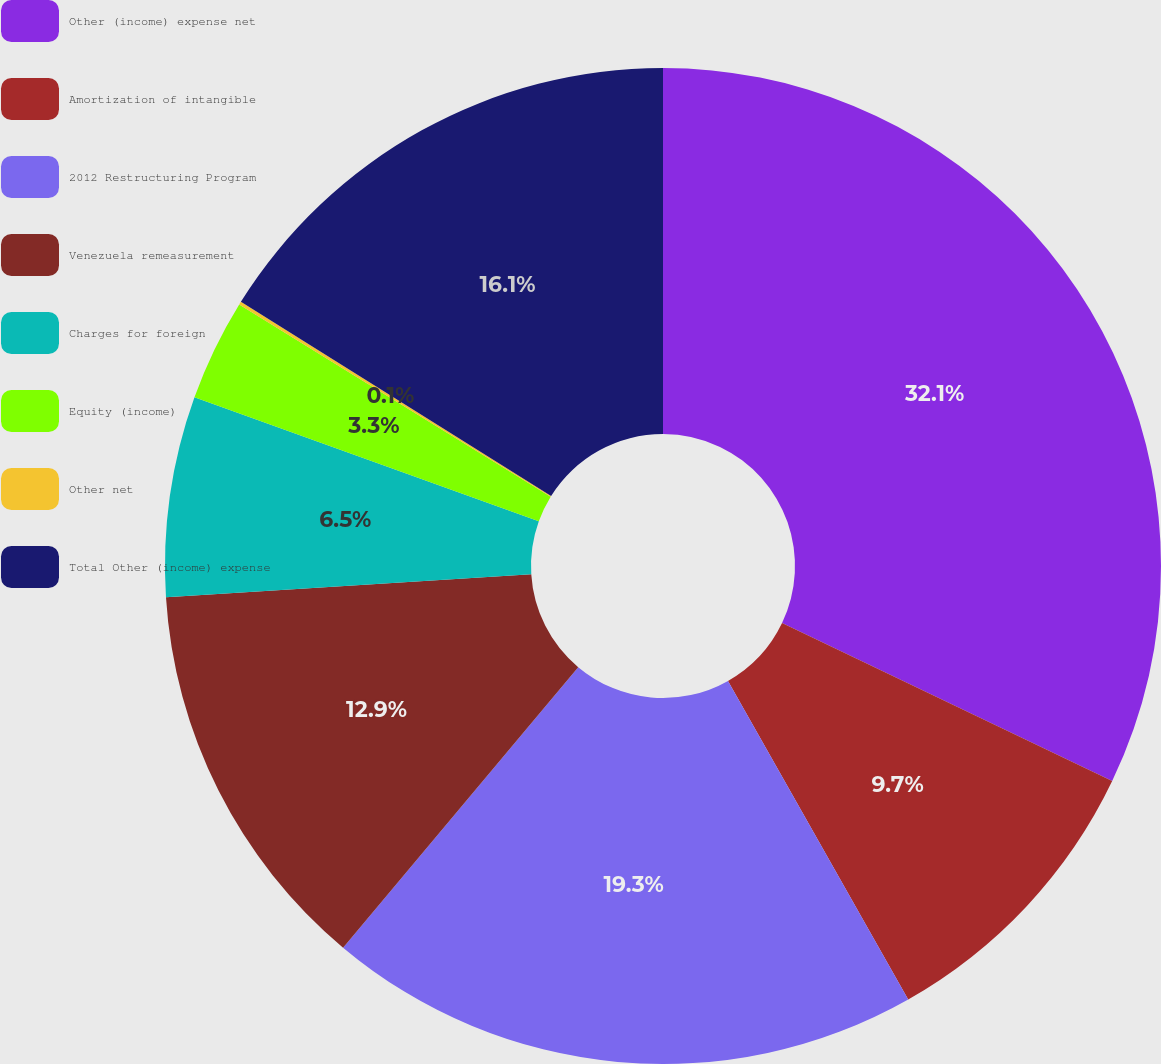Convert chart to OTSL. <chart><loc_0><loc_0><loc_500><loc_500><pie_chart><fcel>Other (income) expense net<fcel>Amortization of intangible<fcel>2012 Restructuring Program<fcel>Venezuela remeasurement<fcel>Charges for foreign<fcel>Equity (income)<fcel>Other net<fcel>Total Other (income) expense<nl><fcel>32.11%<fcel>9.7%<fcel>19.3%<fcel>12.9%<fcel>6.5%<fcel>3.3%<fcel>0.1%<fcel>16.1%<nl></chart> 